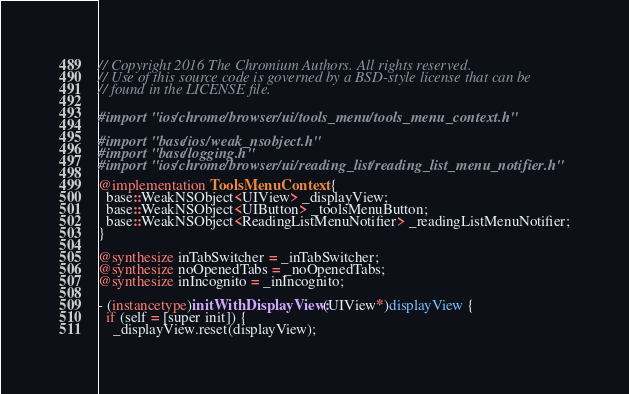Convert code to text. <code><loc_0><loc_0><loc_500><loc_500><_ObjectiveC_>// Copyright 2016 The Chromium Authors. All rights reserved.
// Use of this source code is governed by a BSD-style license that can be
// found in the LICENSE file.

#import "ios/chrome/browser/ui/tools_menu/tools_menu_context.h"

#import "base/ios/weak_nsobject.h"
#import "base/logging.h"
#import "ios/chrome/browser/ui/reading_list/reading_list_menu_notifier.h"

@implementation ToolsMenuContext {
  base::WeakNSObject<UIView> _displayView;
  base::WeakNSObject<UIButton> _toolsMenuButton;
  base::WeakNSObject<ReadingListMenuNotifier> _readingListMenuNotifier;
}

@synthesize inTabSwitcher = _inTabSwitcher;
@synthesize noOpenedTabs = _noOpenedTabs;
@synthesize inIncognito = _inIncognito;

- (instancetype)initWithDisplayView:(UIView*)displayView {
  if (self = [super init]) {
    _displayView.reset(displayView);</code> 